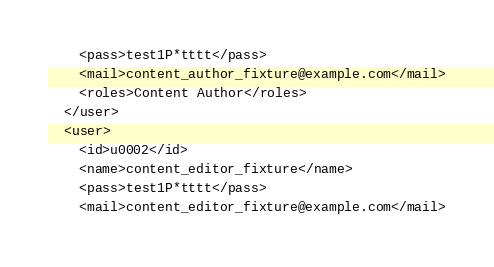<code> <loc_0><loc_0><loc_500><loc_500><_XML_>    <pass>test1P*tttt</pass>
    <mail>content_author_fixture@example.com</mail>
    <roles>Content Author</roles>
  </user>
  <user>
    <id>u0002</id>
    <name>content_editor_fixture</name>
    <pass>test1P*tttt</pass>
    <mail>content_editor_fixture@example.com</mail></code> 